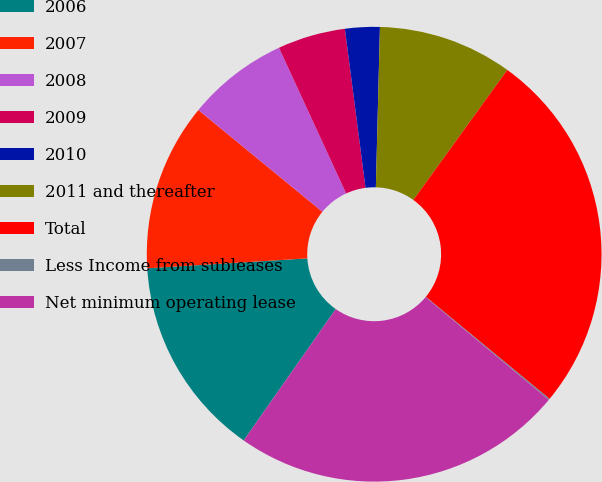Convert chart. <chart><loc_0><loc_0><loc_500><loc_500><pie_chart><fcel>2006<fcel>2007<fcel>2008<fcel>2009<fcel>2010<fcel>2011 and thereafter<fcel>Total<fcel>Less Income from subleases<fcel>Net minimum operating lease<nl><fcel>14.29%<fcel>11.92%<fcel>7.19%<fcel>4.82%<fcel>2.46%<fcel>9.55%<fcel>26.02%<fcel>0.09%<fcel>23.66%<nl></chart> 